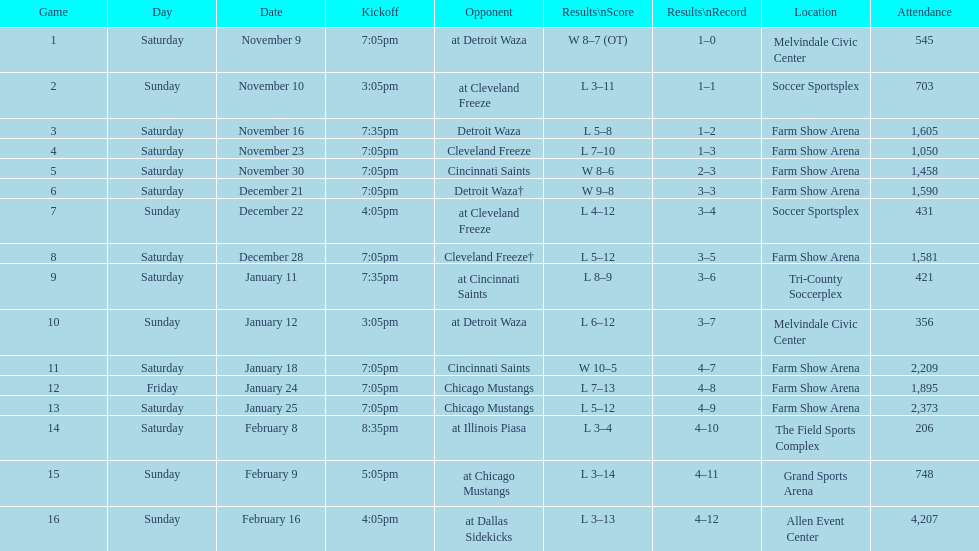What is the date of the game following december 22? December 28. 